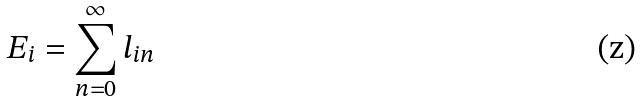<formula> <loc_0><loc_0><loc_500><loc_500>E _ { i } = \sum _ { n = 0 } ^ { \infty } l _ { i n }</formula> 